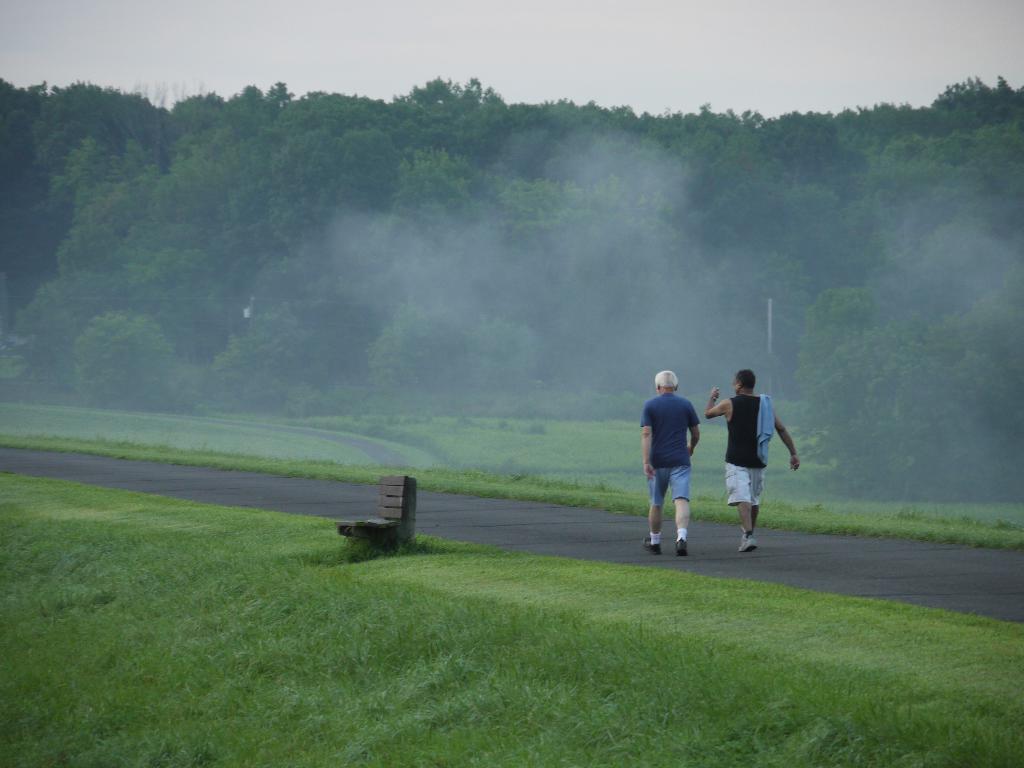Please provide a concise description of this image. The man in blue T-shirt and the man in black T-shirt are walking on the road. At the bottom of the picture, we see grass. There are trees in the background. At the top of the picture, we see the sky. This picture is clicked in the outskirts. 